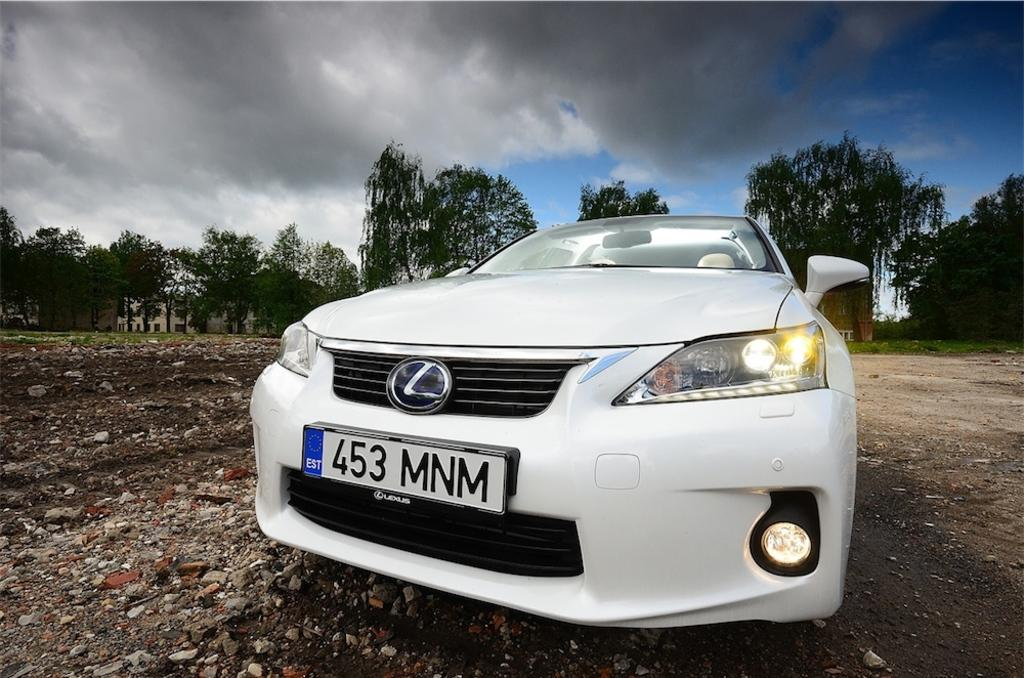What color is the car in the image? The car in the image is white. What type of natural elements can be seen in the image? There are trees visible in the image. What type of structures are in the background of the image? There are buildings in the background of the image. How would you describe the sky in the image? The sky is blue and cloudy in the image. What type of surface is the car parked on? There are stones on the ground in the image. What type of curve can be seen in the image? There is no curve visible in the image. 